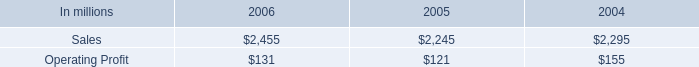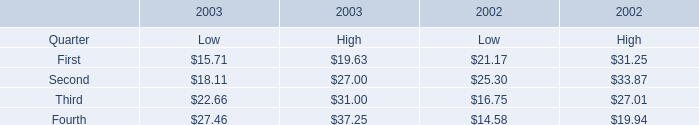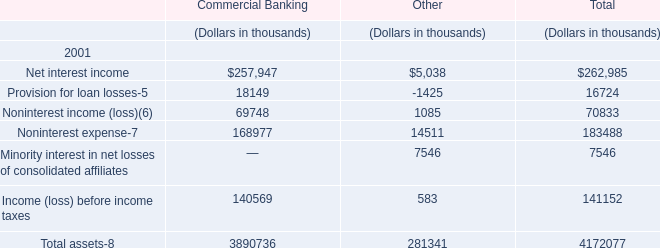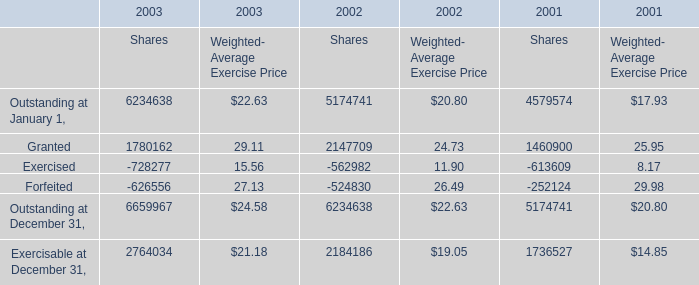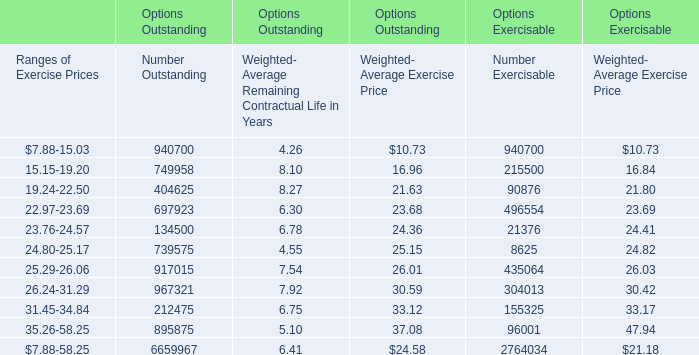What's the current growth rate of Outstanding at January 1 for Weighted- Average Exercise Price? 
Computations: ((22.63 - 20.8) / 20.8)
Answer: 0.08798. 